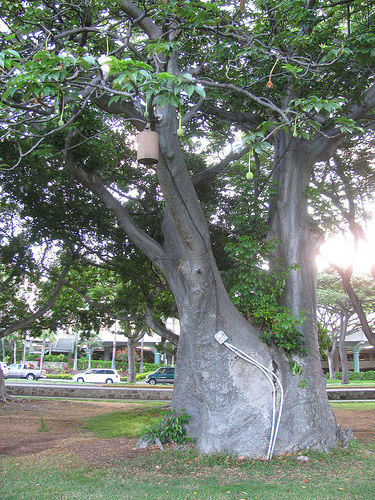<image>
Is there a car on the grass? No. The car is not positioned on the grass. They may be near each other, but the car is not supported by or resting on top of the grass. 